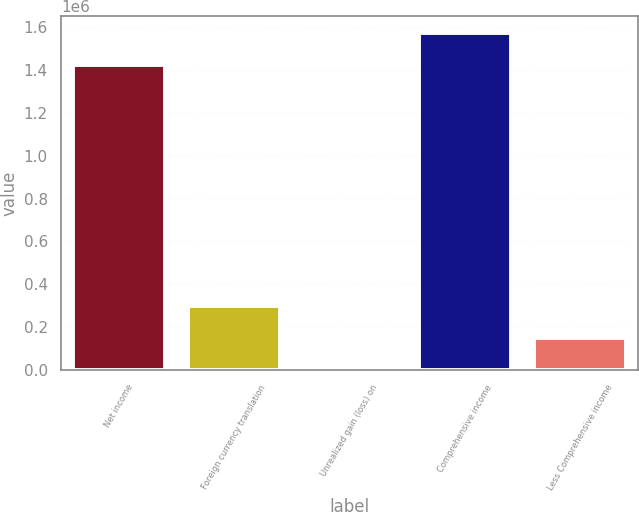Convert chart to OTSL. <chart><loc_0><loc_0><loc_500><loc_500><bar_chart><fcel>Net income<fcel>Foreign currency translation<fcel>Unrealized gain (loss) on<fcel>Comprehensive income<fcel>Less Comprehensive income<nl><fcel>1.42404e+06<fcel>299116<fcel>620<fcel>1.57328e+06<fcel>149868<nl></chart> 